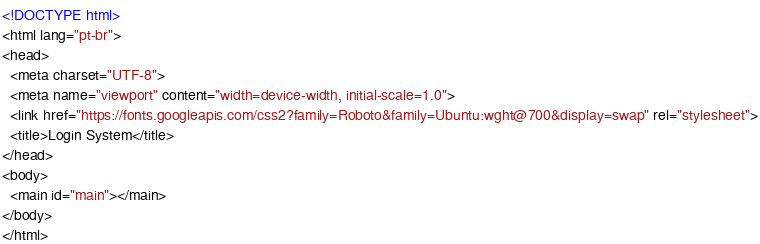<code> <loc_0><loc_0><loc_500><loc_500><_HTML_><!DOCTYPE html>
<html lang="pt-br">
<head>
  <meta charset="UTF-8">
  <meta name="viewport" content="width=device-width, initial-scale=1.0">
  <link href="https://fonts.googleapis.com/css2?family=Roboto&family=Ubuntu:wght@700&display=swap" rel="stylesheet">
  <title>Login System</title>
</head>
<body>
  <main id="main"></main>
</body>
</html></code> 